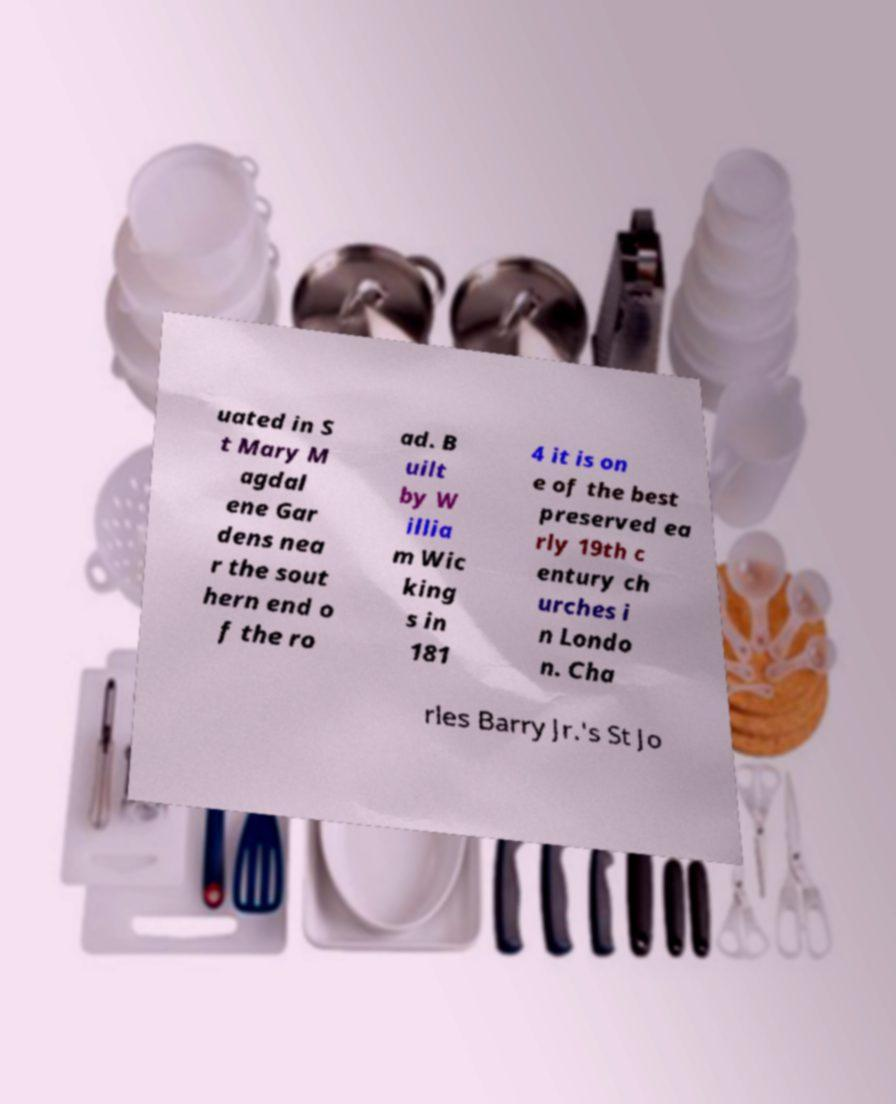Could you extract and type out the text from this image? uated in S t Mary M agdal ene Gar dens nea r the sout hern end o f the ro ad. B uilt by W illia m Wic king s in 181 4 it is on e of the best preserved ea rly 19th c entury ch urches i n Londo n. Cha rles Barry Jr.'s St Jo 